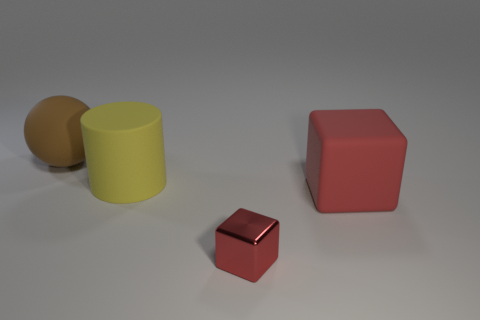Add 2 spheres. How many objects exist? 6 Subtract all cylinders. How many objects are left? 3 Add 2 red blocks. How many red blocks exist? 4 Subtract 1 brown spheres. How many objects are left? 3 Subtract all red matte blocks. Subtract all brown objects. How many objects are left? 2 Add 3 tiny things. How many tiny things are left? 4 